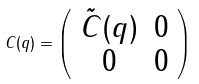Convert formula to latex. <formula><loc_0><loc_0><loc_500><loc_500>C ( q ) = \left ( \begin{array} { c c } \tilde { C } ( q ) & 0 \\ 0 & 0 \end{array} \right )</formula> 